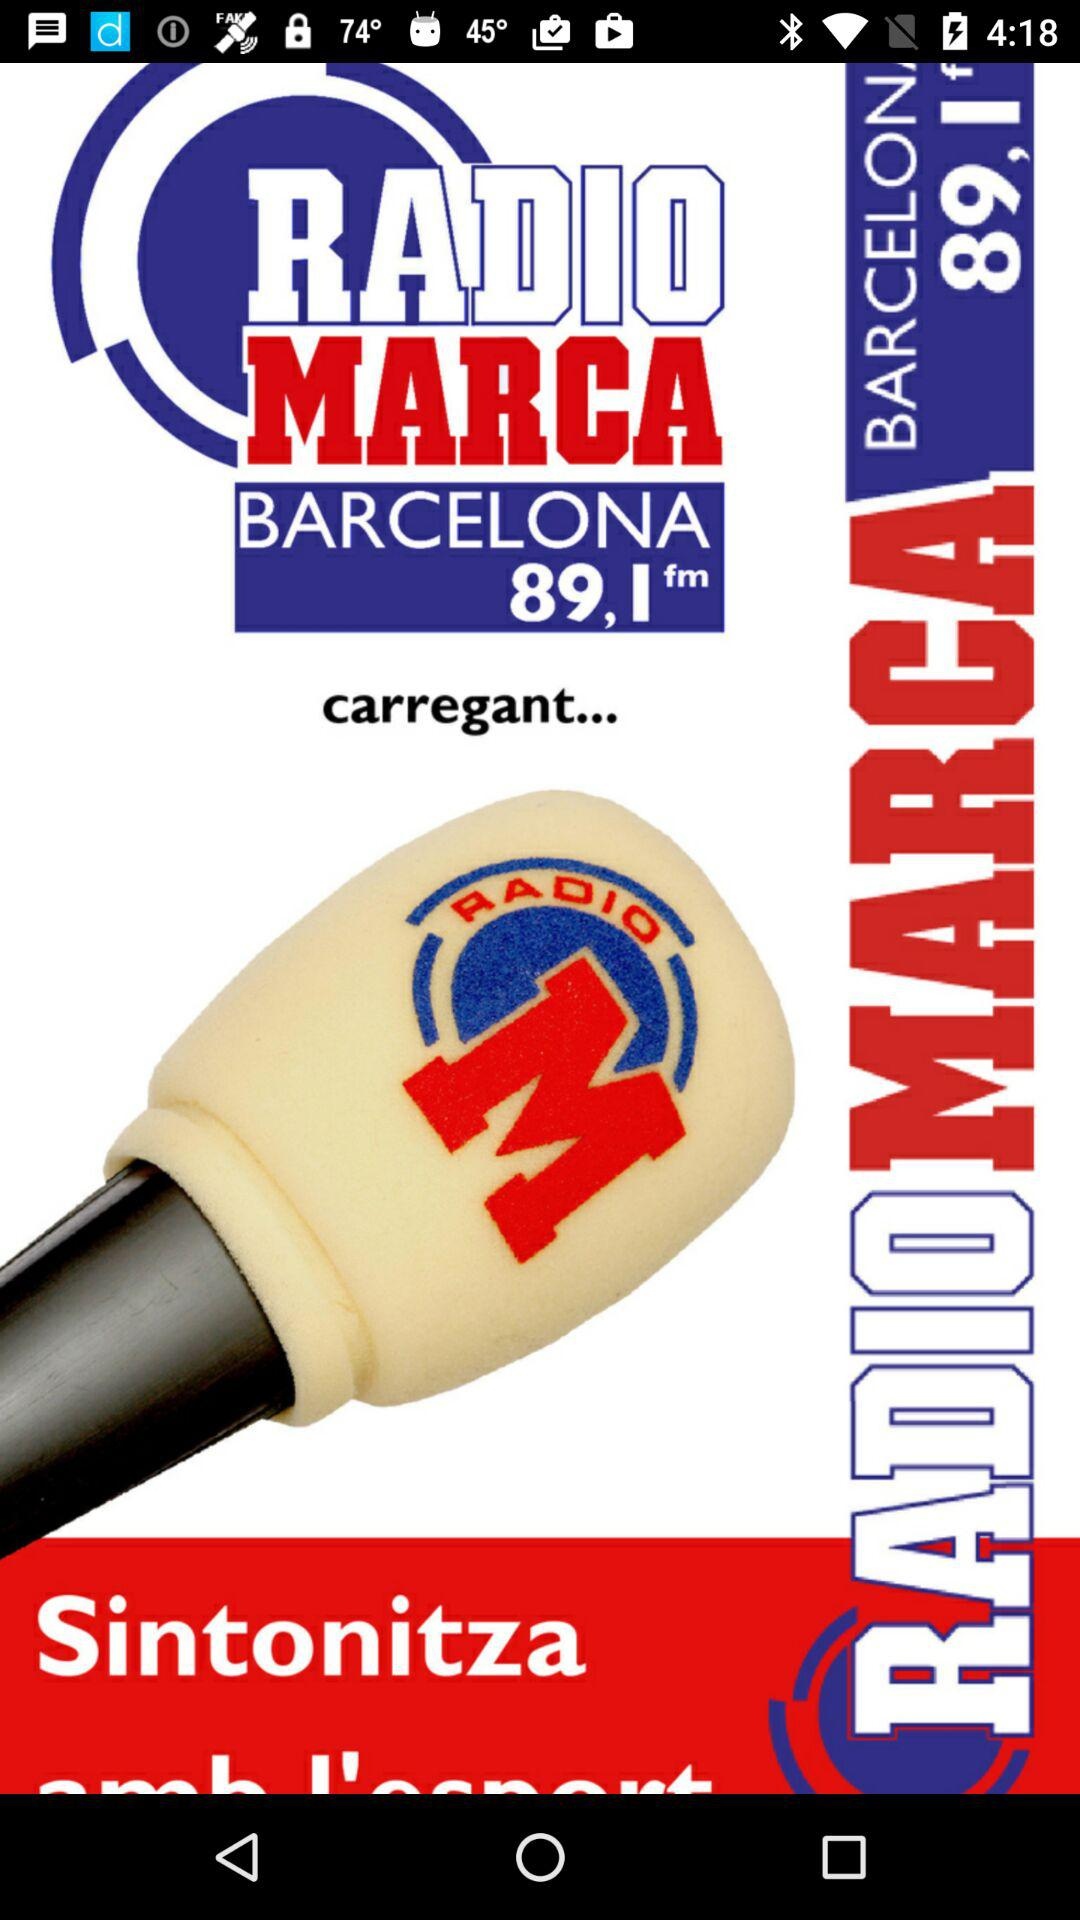What is the name of the currently playing song?
When the provided information is insufficient, respond with <no answer>. <no answer> 